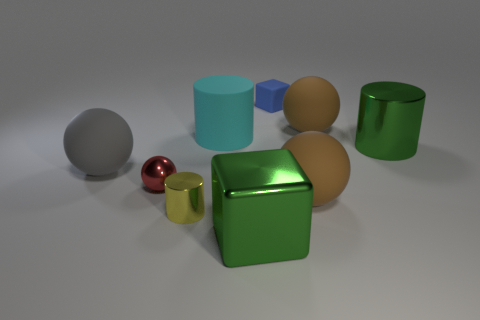What textures are present among the objects? The objects depicted vary in texture; some have a smooth, reflective surface, while others appear to be matte with less specular reflection. 